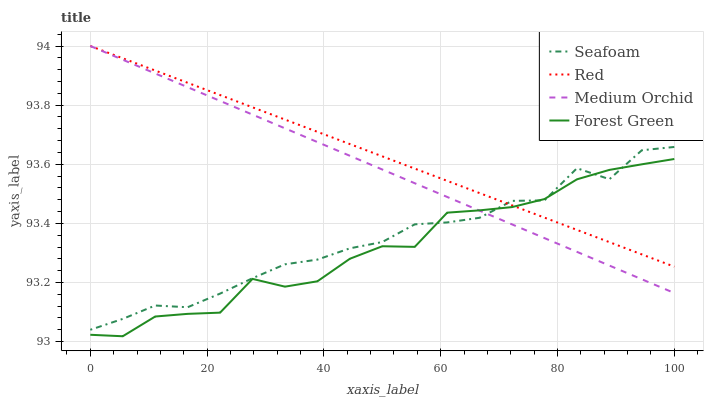Does Medium Orchid have the minimum area under the curve?
Answer yes or no. No. Does Medium Orchid have the maximum area under the curve?
Answer yes or no. No. Is Seafoam the smoothest?
Answer yes or no. No. Is Seafoam the roughest?
Answer yes or no. No. Does Medium Orchid have the lowest value?
Answer yes or no. No. Does Seafoam have the highest value?
Answer yes or no. No. 